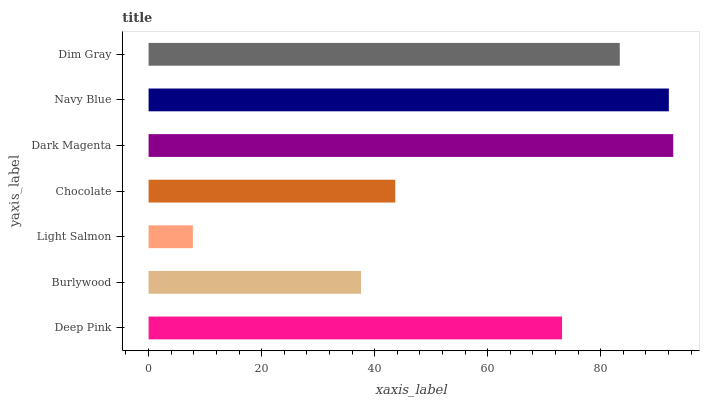Is Light Salmon the minimum?
Answer yes or no. Yes. Is Dark Magenta the maximum?
Answer yes or no. Yes. Is Burlywood the minimum?
Answer yes or no. No. Is Burlywood the maximum?
Answer yes or no. No. Is Deep Pink greater than Burlywood?
Answer yes or no. Yes. Is Burlywood less than Deep Pink?
Answer yes or no. Yes. Is Burlywood greater than Deep Pink?
Answer yes or no. No. Is Deep Pink less than Burlywood?
Answer yes or no. No. Is Deep Pink the high median?
Answer yes or no. Yes. Is Deep Pink the low median?
Answer yes or no. Yes. Is Light Salmon the high median?
Answer yes or no. No. Is Burlywood the low median?
Answer yes or no. No. 